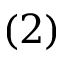Convert formula to latex. <formula><loc_0><loc_0><loc_500><loc_500>( 2 )</formula> 